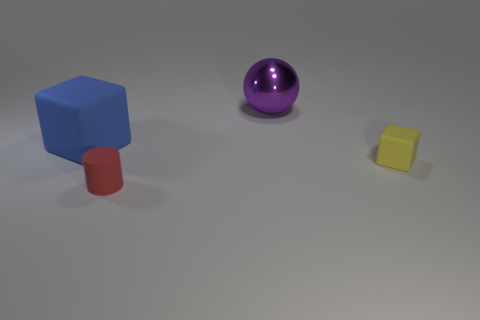There is a block in front of the matte block behind the yellow object; are there any large balls that are right of it?
Give a very brief answer. No. Is the number of small red cylinders to the right of the yellow cube less than the number of red matte cylinders behind the large blue matte object?
Your answer should be compact. No. How many other blocks are the same material as the large blue cube?
Offer a very short reply. 1. There is a sphere; does it have the same size as the matte block that is to the right of the big matte block?
Your answer should be compact. No. What is the size of the rubber object that is behind the tiny yellow rubber object behind the thing that is in front of the yellow cube?
Offer a terse response. Large. Are there more tiny yellow things that are on the left side of the tiny rubber cylinder than yellow blocks behind the yellow block?
Your answer should be very brief. No. There is a cube that is to the left of the large purple metal object; how many blue things are left of it?
Ensure brevity in your answer.  0. Is there another large sphere that has the same color as the sphere?
Offer a very short reply. No. Do the purple object and the rubber cylinder have the same size?
Provide a short and direct response. No. Do the large metal ball and the cylinder have the same color?
Your response must be concise. No. 